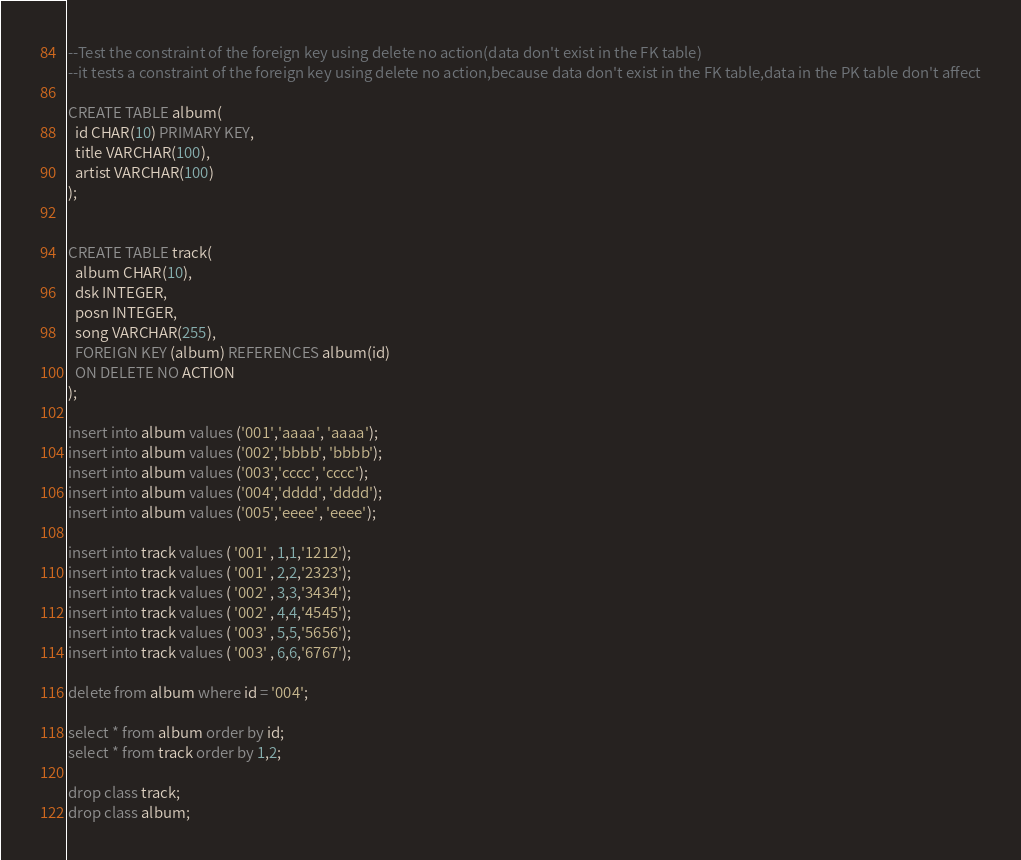Convert code to text. <code><loc_0><loc_0><loc_500><loc_500><_SQL_>--Test the constraint of the foreign key using delete no action(data don't exist in the FK table)
--it tests a constraint of the foreign key using delete no action,because data don't exist in the FK table,data in the PK table don't affect

CREATE TABLE album(
  id CHAR(10) PRIMARY KEY,
  title VARCHAR(100),
  artist VARCHAR(100)
);


CREATE TABLE track(
  album CHAR(10),
  dsk INTEGER,
  posn INTEGER,
  song VARCHAR(255),
  FOREIGN KEY (album) REFERENCES album(id)
  ON DELETE NO ACTION
);

insert into album values ('001','aaaa', 'aaaa');
insert into album values ('002','bbbb', 'bbbb');
insert into album values ('003','cccc', 'cccc');
insert into album values ('004','dddd', 'dddd');
insert into album values ('005','eeee', 'eeee');

insert into track values ( '001' , 1,1,'1212');
insert into track values ( '001' , 2,2,'2323');
insert into track values ( '002' , 3,3,'3434');
insert into track values ( '002' , 4,4,'4545');
insert into track values ( '003' , 5,5,'5656');
insert into track values ( '003' , 6,6,'6767');

delete from album where id = '004';

select * from album order by id;
select * from track order by 1,2;

drop class track;
drop class album;
</code> 